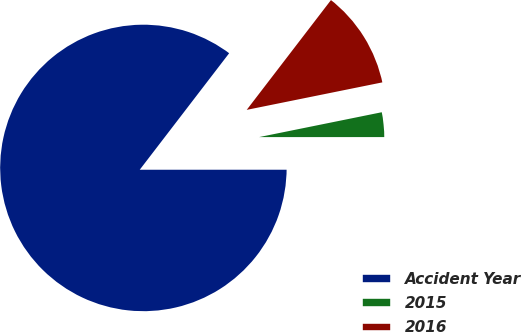Convert chart to OTSL. <chart><loc_0><loc_0><loc_500><loc_500><pie_chart><fcel>Accident Year<fcel>2015<fcel>2016<nl><fcel>85.42%<fcel>3.18%<fcel>11.4%<nl></chart> 